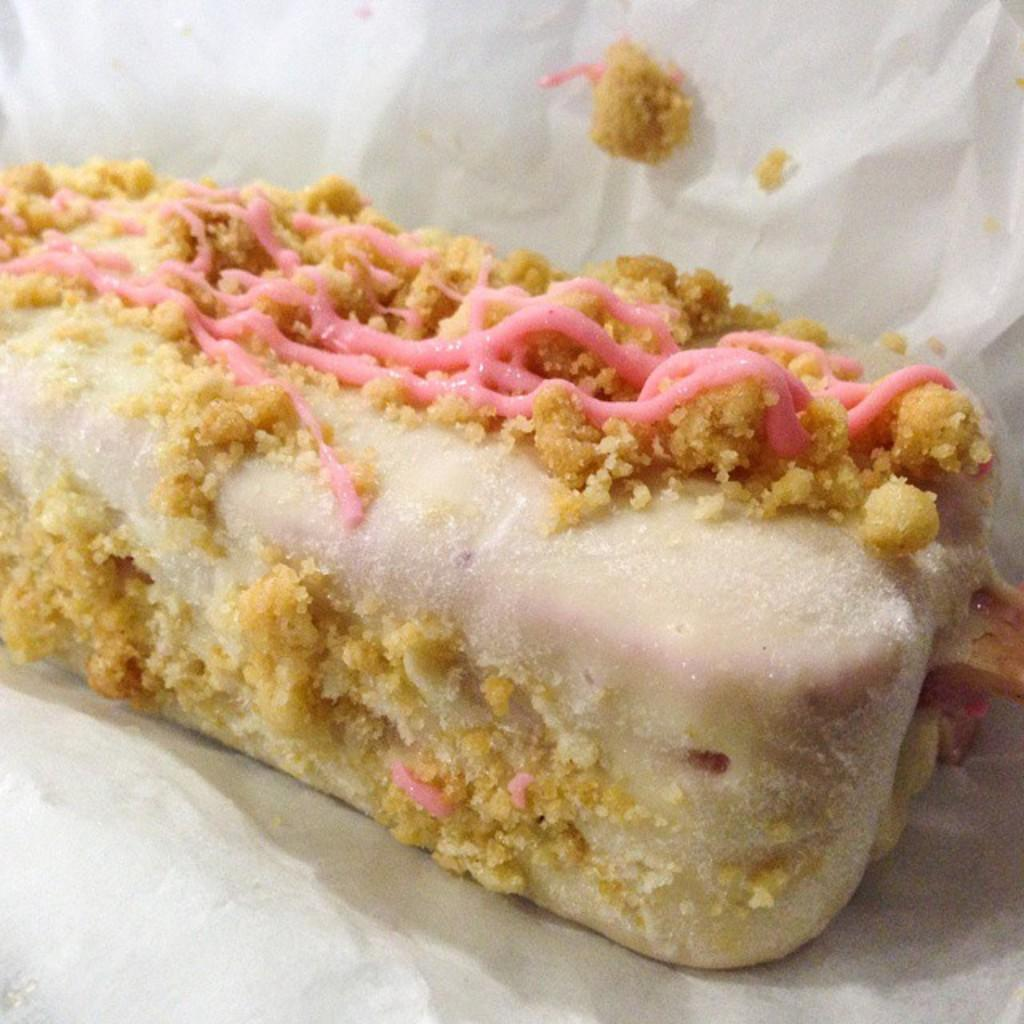What is the main subject of the image? There is a food item in the image. How is the food item presented in the image? The food item is wrapped in paper. What type of gun is the doctor holding in the image? There is no doctor or gun present in the image; it only features a food item wrapped in paper. 